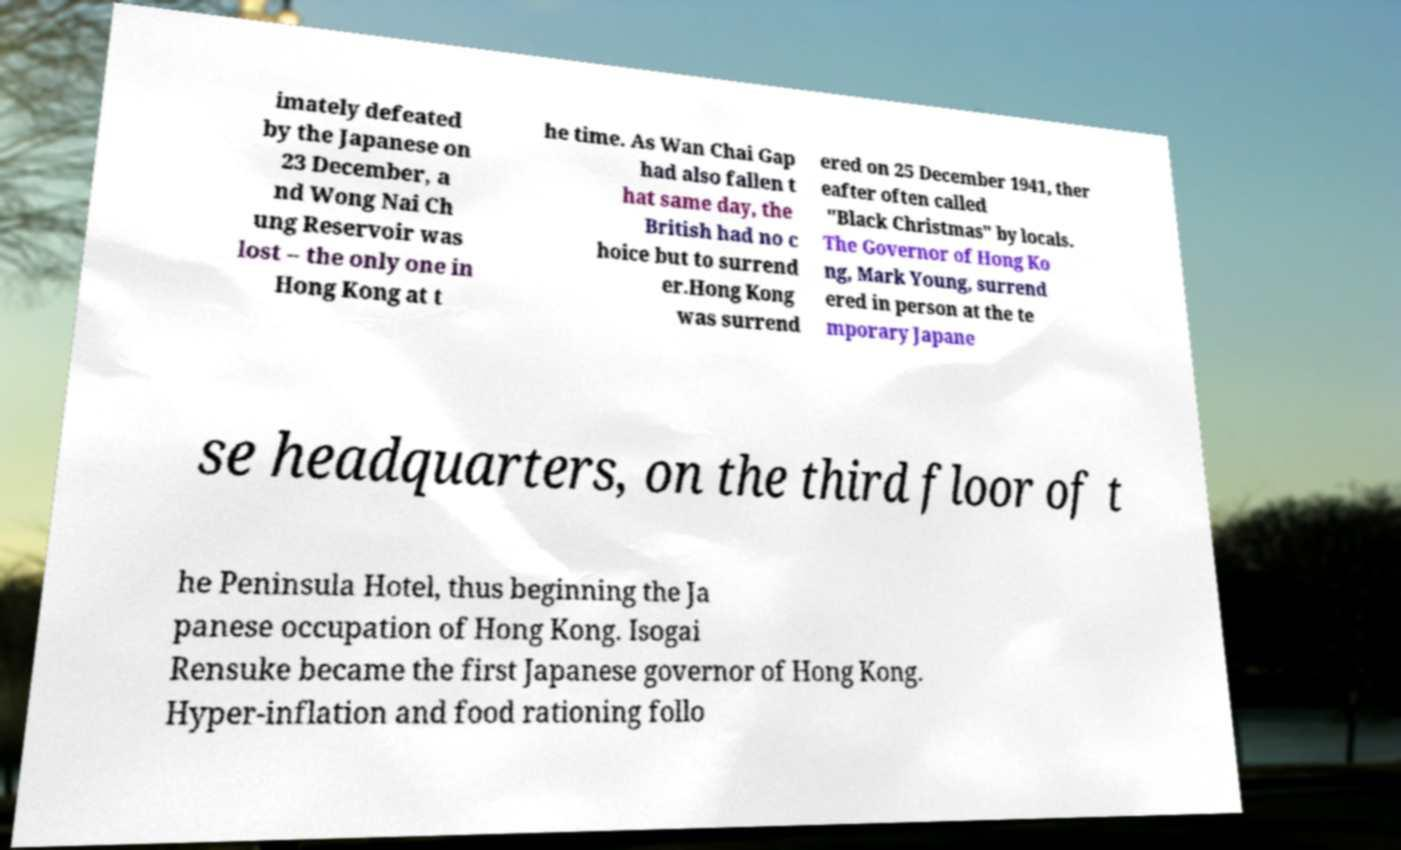Can you accurately transcribe the text from the provided image for me? imately defeated by the Japanese on 23 December, a nd Wong Nai Ch ung Reservoir was lost – the only one in Hong Kong at t he time. As Wan Chai Gap had also fallen t hat same day, the British had no c hoice but to surrend er.Hong Kong was surrend ered on 25 December 1941, ther eafter often called "Black Christmas" by locals. The Governor of Hong Ko ng, Mark Young, surrend ered in person at the te mporary Japane se headquarters, on the third floor of t he Peninsula Hotel, thus beginning the Ja panese occupation of Hong Kong. Isogai Rensuke became the first Japanese governor of Hong Kong. Hyper-inflation and food rationing follo 